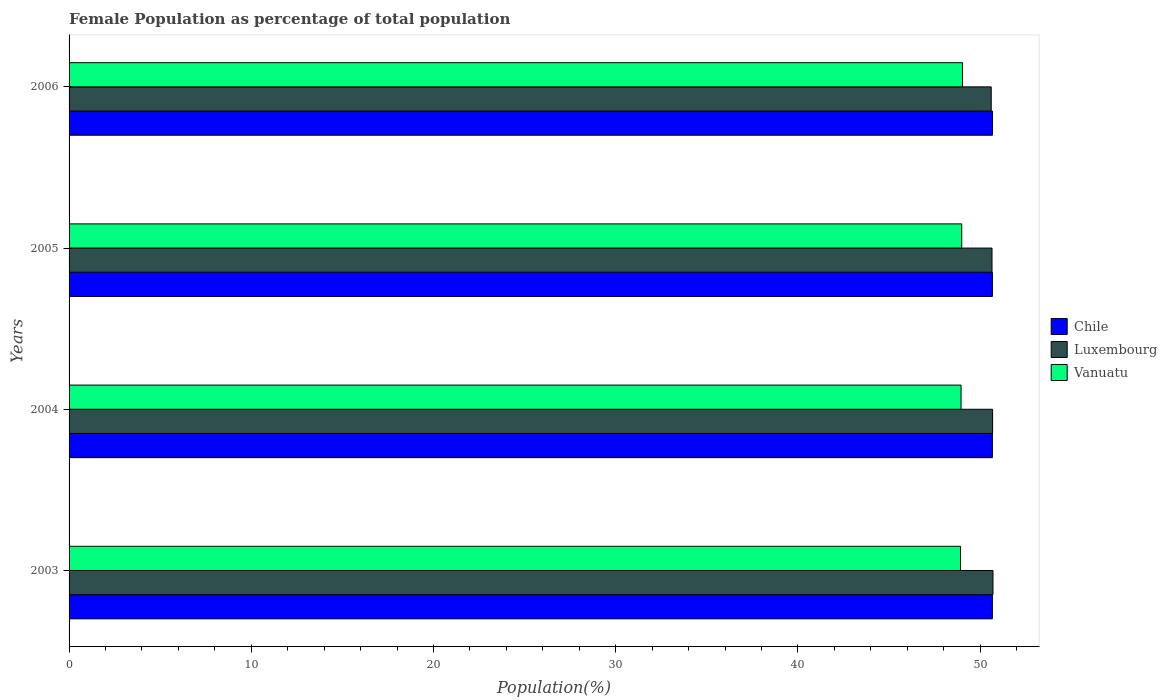How many different coloured bars are there?
Ensure brevity in your answer.  3. Are the number of bars per tick equal to the number of legend labels?
Your response must be concise. Yes. Are the number of bars on each tick of the Y-axis equal?
Make the answer very short. Yes. How many bars are there on the 1st tick from the top?
Your answer should be very brief. 3. What is the female population in in Chile in 2003?
Give a very brief answer. 50.67. Across all years, what is the maximum female population in in Chile?
Keep it short and to the point. 50.68. Across all years, what is the minimum female population in in Chile?
Make the answer very short. 50.67. In which year was the female population in in Vanuatu maximum?
Keep it short and to the point. 2006. What is the total female population in in Luxembourg in the graph?
Provide a short and direct response. 202.66. What is the difference between the female population in in Luxembourg in 2004 and that in 2006?
Provide a succinct answer. 0.08. What is the difference between the female population in in Chile in 2006 and the female population in in Vanuatu in 2003?
Give a very brief answer. 1.75. What is the average female population in in Vanuatu per year?
Make the answer very short. 48.98. In the year 2004, what is the difference between the female population in in Vanuatu and female population in in Chile?
Ensure brevity in your answer.  -1.72. In how many years, is the female population in in Luxembourg greater than 38 %?
Offer a terse response. 4. What is the ratio of the female population in in Luxembourg in 2003 to that in 2006?
Offer a terse response. 1. Is the difference between the female population in in Vanuatu in 2003 and 2004 greater than the difference between the female population in in Chile in 2003 and 2004?
Your answer should be very brief. No. What is the difference between the highest and the second highest female population in in Chile?
Your answer should be compact. 0. What is the difference between the highest and the lowest female population in in Chile?
Offer a terse response. 0. What does the 3rd bar from the bottom in 2004 represents?
Make the answer very short. Vanuatu. Is it the case that in every year, the sum of the female population in in Vanuatu and female population in in Chile is greater than the female population in in Luxembourg?
Offer a very short reply. Yes. Are all the bars in the graph horizontal?
Provide a short and direct response. Yes. What is the difference between two consecutive major ticks on the X-axis?
Your response must be concise. 10. Are the values on the major ticks of X-axis written in scientific E-notation?
Provide a short and direct response. No. How are the legend labels stacked?
Your response must be concise. Vertical. What is the title of the graph?
Make the answer very short. Female Population as percentage of total population. What is the label or title of the X-axis?
Keep it short and to the point. Population(%). What is the label or title of the Y-axis?
Offer a very short reply. Years. What is the Population(%) of Chile in 2003?
Give a very brief answer. 50.67. What is the Population(%) of Luxembourg in 2003?
Give a very brief answer. 50.71. What is the Population(%) in Vanuatu in 2003?
Ensure brevity in your answer.  48.93. What is the Population(%) in Chile in 2004?
Make the answer very short. 50.67. What is the Population(%) of Luxembourg in 2004?
Keep it short and to the point. 50.69. What is the Population(%) of Vanuatu in 2004?
Keep it short and to the point. 48.96. What is the Population(%) of Chile in 2005?
Give a very brief answer. 50.68. What is the Population(%) in Luxembourg in 2005?
Provide a short and direct response. 50.65. What is the Population(%) of Vanuatu in 2005?
Ensure brevity in your answer.  48.99. What is the Population(%) of Chile in 2006?
Keep it short and to the point. 50.68. What is the Population(%) of Luxembourg in 2006?
Keep it short and to the point. 50.61. What is the Population(%) of Vanuatu in 2006?
Provide a short and direct response. 49.04. Across all years, what is the maximum Population(%) in Chile?
Make the answer very short. 50.68. Across all years, what is the maximum Population(%) in Luxembourg?
Keep it short and to the point. 50.71. Across all years, what is the maximum Population(%) of Vanuatu?
Provide a short and direct response. 49.04. Across all years, what is the minimum Population(%) of Chile?
Provide a short and direct response. 50.67. Across all years, what is the minimum Population(%) of Luxembourg?
Give a very brief answer. 50.61. Across all years, what is the minimum Population(%) in Vanuatu?
Your answer should be very brief. 48.93. What is the total Population(%) in Chile in the graph?
Your response must be concise. 202.7. What is the total Population(%) in Luxembourg in the graph?
Provide a short and direct response. 202.66. What is the total Population(%) in Vanuatu in the graph?
Provide a succinct answer. 195.91. What is the difference between the Population(%) in Chile in 2003 and that in 2004?
Offer a terse response. -0. What is the difference between the Population(%) of Luxembourg in 2003 and that in 2004?
Provide a succinct answer. 0.02. What is the difference between the Population(%) in Vanuatu in 2003 and that in 2004?
Keep it short and to the point. -0.03. What is the difference between the Population(%) in Chile in 2003 and that in 2005?
Offer a very short reply. -0. What is the difference between the Population(%) in Luxembourg in 2003 and that in 2005?
Provide a short and direct response. 0.05. What is the difference between the Population(%) in Vanuatu in 2003 and that in 2005?
Ensure brevity in your answer.  -0.06. What is the difference between the Population(%) in Chile in 2003 and that in 2006?
Offer a terse response. -0. What is the difference between the Population(%) of Luxembourg in 2003 and that in 2006?
Offer a terse response. 0.1. What is the difference between the Population(%) in Vanuatu in 2003 and that in 2006?
Give a very brief answer. -0.11. What is the difference between the Population(%) in Chile in 2004 and that in 2005?
Offer a very short reply. -0. What is the difference between the Population(%) of Luxembourg in 2004 and that in 2005?
Offer a terse response. 0.03. What is the difference between the Population(%) in Vanuatu in 2004 and that in 2005?
Provide a succinct answer. -0.04. What is the difference between the Population(%) of Chile in 2004 and that in 2006?
Keep it short and to the point. -0. What is the difference between the Population(%) of Luxembourg in 2004 and that in 2006?
Your response must be concise. 0.08. What is the difference between the Population(%) of Vanuatu in 2004 and that in 2006?
Give a very brief answer. -0.08. What is the difference between the Population(%) in Chile in 2005 and that in 2006?
Provide a succinct answer. -0. What is the difference between the Population(%) in Luxembourg in 2005 and that in 2006?
Your response must be concise. 0.04. What is the difference between the Population(%) in Vanuatu in 2005 and that in 2006?
Give a very brief answer. -0.05. What is the difference between the Population(%) of Chile in 2003 and the Population(%) of Luxembourg in 2004?
Keep it short and to the point. -0.01. What is the difference between the Population(%) in Chile in 2003 and the Population(%) in Vanuatu in 2004?
Provide a short and direct response. 1.72. What is the difference between the Population(%) in Luxembourg in 2003 and the Population(%) in Vanuatu in 2004?
Offer a very short reply. 1.75. What is the difference between the Population(%) of Chile in 2003 and the Population(%) of Luxembourg in 2005?
Provide a short and direct response. 0.02. What is the difference between the Population(%) in Chile in 2003 and the Population(%) in Vanuatu in 2005?
Offer a very short reply. 1.68. What is the difference between the Population(%) in Luxembourg in 2003 and the Population(%) in Vanuatu in 2005?
Provide a short and direct response. 1.72. What is the difference between the Population(%) of Chile in 2003 and the Population(%) of Luxembourg in 2006?
Make the answer very short. 0.06. What is the difference between the Population(%) of Chile in 2003 and the Population(%) of Vanuatu in 2006?
Offer a very short reply. 1.64. What is the difference between the Population(%) of Luxembourg in 2003 and the Population(%) of Vanuatu in 2006?
Give a very brief answer. 1.67. What is the difference between the Population(%) of Chile in 2004 and the Population(%) of Luxembourg in 2005?
Provide a succinct answer. 0.02. What is the difference between the Population(%) of Chile in 2004 and the Population(%) of Vanuatu in 2005?
Make the answer very short. 1.68. What is the difference between the Population(%) in Luxembourg in 2004 and the Population(%) in Vanuatu in 2005?
Keep it short and to the point. 1.69. What is the difference between the Population(%) in Chile in 2004 and the Population(%) in Luxembourg in 2006?
Ensure brevity in your answer.  0.06. What is the difference between the Population(%) in Chile in 2004 and the Population(%) in Vanuatu in 2006?
Your response must be concise. 1.64. What is the difference between the Population(%) in Luxembourg in 2004 and the Population(%) in Vanuatu in 2006?
Provide a succinct answer. 1.65. What is the difference between the Population(%) in Chile in 2005 and the Population(%) in Luxembourg in 2006?
Give a very brief answer. 0.07. What is the difference between the Population(%) in Chile in 2005 and the Population(%) in Vanuatu in 2006?
Ensure brevity in your answer.  1.64. What is the difference between the Population(%) of Luxembourg in 2005 and the Population(%) of Vanuatu in 2006?
Ensure brevity in your answer.  1.62. What is the average Population(%) of Chile per year?
Your response must be concise. 50.68. What is the average Population(%) in Luxembourg per year?
Offer a terse response. 50.66. What is the average Population(%) in Vanuatu per year?
Offer a terse response. 48.98. In the year 2003, what is the difference between the Population(%) of Chile and Population(%) of Luxembourg?
Your answer should be compact. -0.03. In the year 2003, what is the difference between the Population(%) of Chile and Population(%) of Vanuatu?
Ensure brevity in your answer.  1.75. In the year 2003, what is the difference between the Population(%) of Luxembourg and Population(%) of Vanuatu?
Provide a short and direct response. 1.78. In the year 2004, what is the difference between the Population(%) of Chile and Population(%) of Luxembourg?
Offer a very short reply. -0.01. In the year 2004, what is the difference between the Population(%) in Chile and Population(%) in Vanuatu?
Make the answer very short. 1.72. In the year 2004, what is the difference between the Population(%) in Luxembourg and Population(%) in Vanuatu?
Provide a succinct answer. 1.73. In the year 2005, what is the difference between the Population(%) in Chile and Population(%) in Luxembourg?
Ensure brevity in your answer.  0.02. In the year 2005, what is the difference between the Population(%) of Chile and Population(%) of Vanuatu?
Your response must be concise. 1.68. In the year 2005, what is the difference between the Population(%) of Luxembourg and Population(%) of Vanuatu?
Your answer should be very brief. 1.66. In the year 2006, what is the difference between the Population(%) of Chile and Population(%) of Luxembourg?
Keep it short and to the point. 0.07. In the year 2006, what is the difference between the Population(%) in Chile and Population(%) in Vanuatu?
Provide a short and direct response. 1.64. In the year 2006, what is the difference between the Population(%) of Luxembourg and Population(%) of Vanuatu?
Your response must be concise. 1.57. What is the ratio of the Population(%) in Chile in 2003 to that in 2004?
Give a very brief answer. 1. What is the ratio of the Population(%) in Chile in 2003 to that in 2005?
Your response must be concise. 1. What is the ratio of the Population(%) of Chile in 2003 to that in 2006?
Your answer should be compact. 1. What is the ratio of the Population(%) of Vanuatu in 2003 to that in 2006?
Your response must be concise. 1. What is the ratio of the Population(%) in Luxembourg in 2004 to that in 2005?
Your answer should be compact. 1. What is the ratio of the Population(%) of Chile in 2004 to that in 2006?
Offer a very short reply. 1. What is the ratio of the Population(%) of Vanuatu in 2005 to that in 2006?
Your response must be concise. 1. What is the difference between the highest and the second highest Population(%) of Chile?
Offer a very short reply. 0. What is the difference between the highest and the second highest Population(%) in Luxembourg?
Keep it short and to the point. 0.02. What is the difference between the highest and the second highest Population(%) of Vanuatu?
Ensure brevity in your answer.  0.05. What is the difference between the highest and the lowest Population(%) in Chile?
Provide a succinct answer. 0. What is the difference between the highest and the lowest Population(%) of Luxembourg?
Provide a short and direct response. 0.1. What is the difference between the highest and the lowest Population(%) in Vanuatu?
Offer a very short reply. 0.11. 